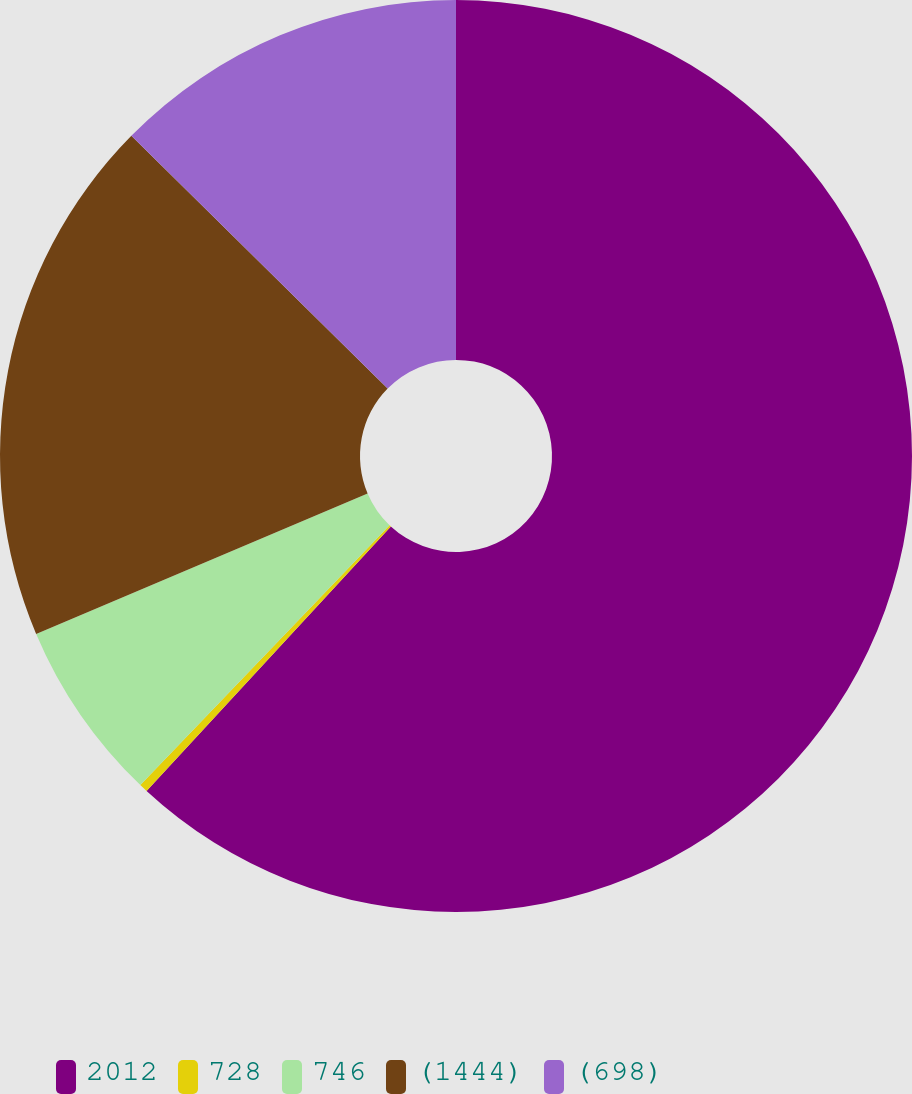<chart> <loc_0><loc_0><loc_500><loc_500><pie_chart><fcel>2012<fcel>728<fcel>746<fcel>(1444)<fcel>(698)<nl><fcel>61.87%<fcel>0.3%<fcel>6.45%<fcel>18.77%<fcel>12.61%<nl></chart> 